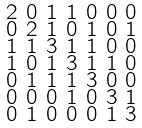<formula> <loc_0><loc_0><loc_500><loc_500>\begin{smallmatrix} 2 & 0 & 1 & 1 & 0 & 0 & 0 \\ 0 & 2 & 1 & 0 & 1 & 0 & 1 \\ 1 & 1 & 3 & 1 & 1 & 0 & 0 \\ 1 & 0 & 1 & 3 & 1 & 1 & 0 \\ 0 & 1 & 1 & 1 & 3 & 0 & 0 \\ 0 & 0 & 0 & 1 & 0 & 3 & 1 \\ 0 & 1 & 0 & 0 & 0 & 1 & 3 \end{smallmatrix}</formula> 